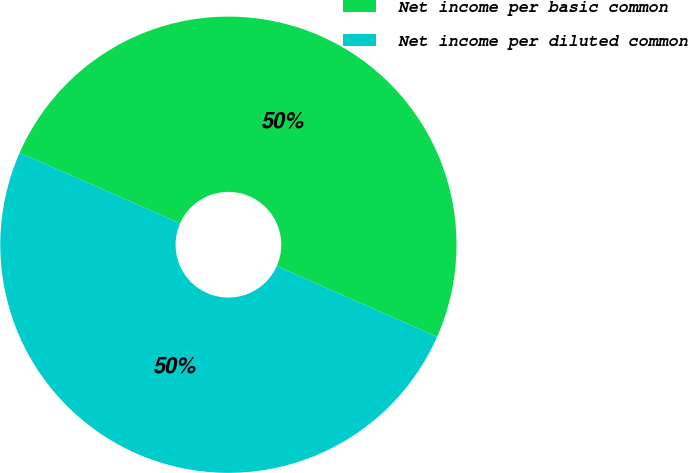Convert chart to OTSL. <chart><loc_0><loc_0><loc_500><loc_500><pie_chart><fcel>Net income per basic common<fcel>Net income per diluted common<nl><fcel>50.0%<fcel>50.0%<nl></chart> 